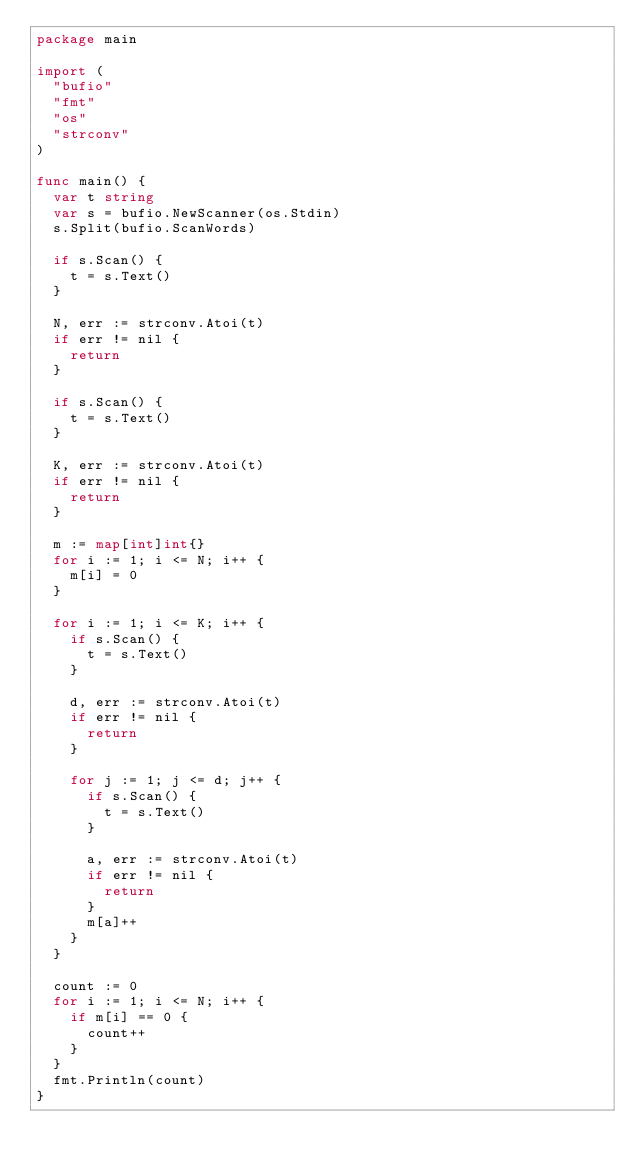<code> <loc_0><loc_0><loc_500><loc_500><_Go_>package main

import (
	"bufio"
	"fmt"
	"os"
	"strconv"
)

func main() {
	var t string
	var s = bufio.NewScanner(os.Stdin)
	s.Split(bufio.ScanWords)

	if s.Scan() {
		t = s.Text()
	}

	N, err := strconv.Atoi(t)
	if err != nil {
		return
	}

	if s.Scan() {
		t = s.Text()
	}

	K, err := strconv.Atoi(t)
	if err != nil {
		return
	}

	m := map[int]int{}
	for i := 1; i <= N; i++ {
		m[i] = 0
	}

	for i := 1; i <= K; i++ {
		if s.Scan() {
			t = s.Text()
		}

		d, err := strconv.Atoi(t)
		if err != nil {
			return
		}

		for j := 1; j <= d; j++ {
			if s.Scan() {
				t = s.Text()
			}

			a, err := strconv.Atoi(t)
			if err != nil {
				return
			}
			m[a]++
		}
	}

	count := 0
	for i := 1; i <= N; i++ {
		if m[i] == 0 {
			count++
		}
	}
	fmt.Println(count)
}
</code> 